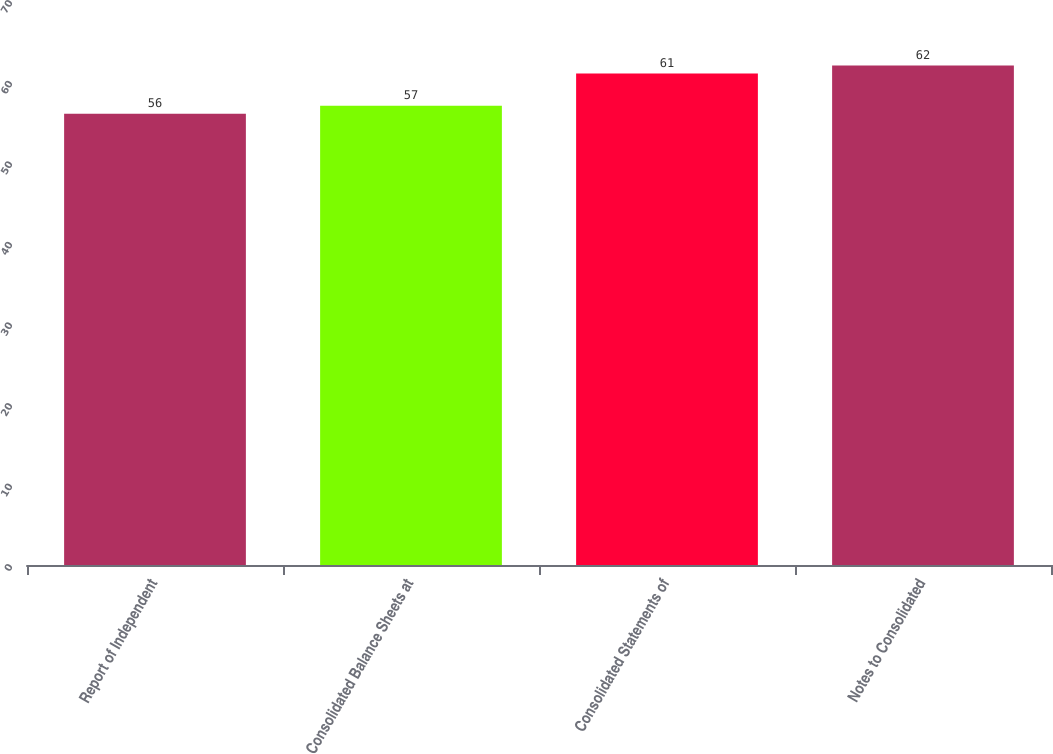Convert chart to OTSL. <chart><loc_0><loc_0><loc_500><loc_500><bar_chart><fcel>Report of Independent<fcel>Consolidated Balance Sheets at<fcel>Consolidated Statements of<fcel>Notes to Consolidated<nl><fcel>56<fcel>57<fcel>61<fcel>62<nl></chart> 